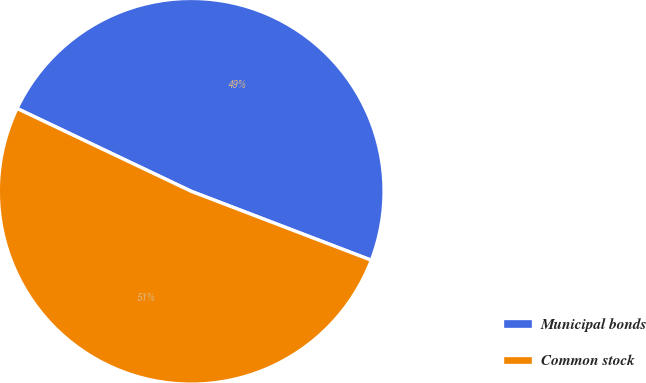Convert chart. <chart><loc_0><loc_0><loc_500><loc_500><pie_chart><fcel>Municipal bonds<fcel>Common stock<nl><fcel>48.75%<fcel>51.25%<nl></chart> 